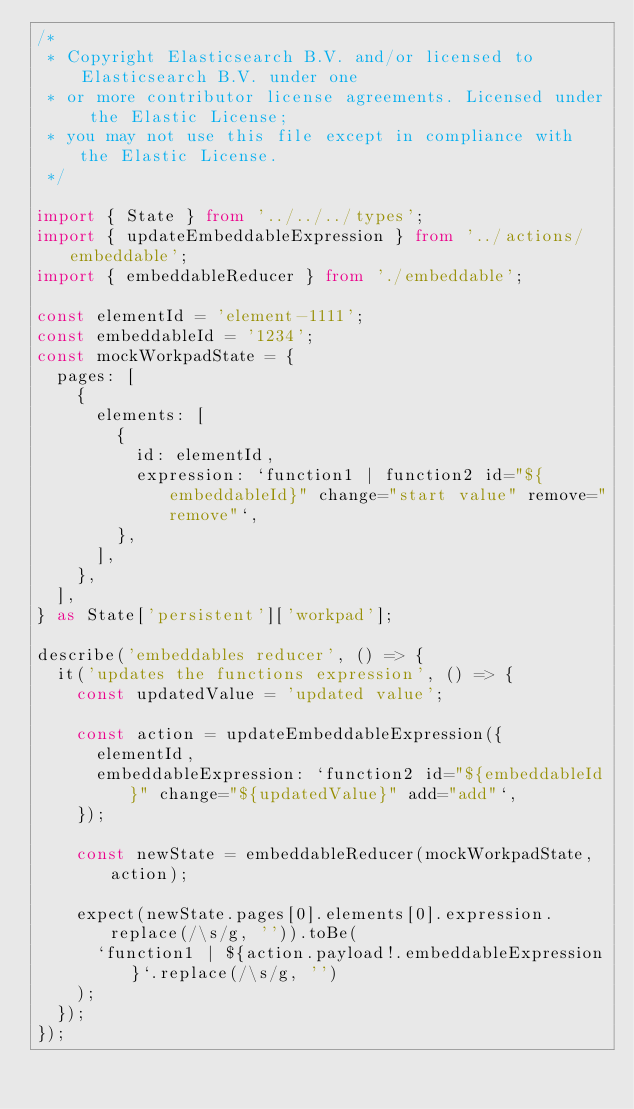Convert code to text. <code><loc_0><loc_0><loc_500><loc_500><_TypeScript_>/*
 * Copyright Elasticsearch B.V. and/or licensed to Elasticsearch B.V. under one
 * or more contributor license agreements. Licensed under the Elastic License;
 * you may not use this file except in compliance with the Elastic License.
 */

import { State } from '../../../types';
import { updateEmbeddableExpression } from '../actions/embeddable';
import { embeddableReducer } from './embeddable';

const elementId = 'element-1111';
const embeddableId = '1234';
const mockWorkpadState = {
  pages: [
    {
      elements: [
        {
          id: elementId,
          expression: `function1 | function2 id="${embeddableId}" change="start value" remove="remove"`,
        },
      ],
    },
  ],
} as State['persistent']['workpad'];

describe('embeddables reducer', () => {
  it('updates the functions expression', () => {
    const updatedValue = 'updated value';

    const action = updateEmbeddableExpression({
      elementId,
      embeddableExpression: `function2 id="${embeddableId}" change="${updatedValue}" add="add"`,
    });

    const newState = embeddableReducer(mockWorkpadState, action);

    expect(newState.pages[0].elements[0].expression.replace(/\s/g, '')).toBe(
      `function1 | ${action.payload!.embeddableExpression}`.replace(/\s/g, '')
    );
  });
});
</code> 